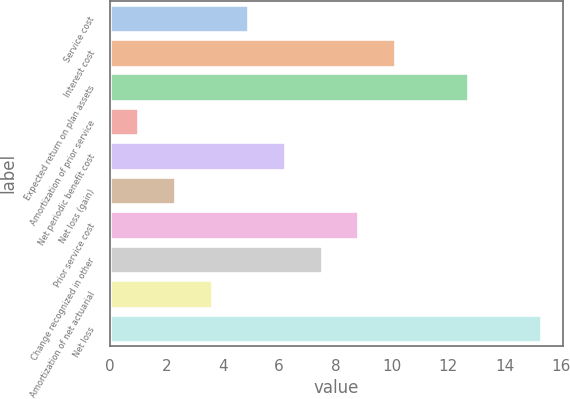Convert chart. <chart><loc_0><loc_0><loc_500><loc_500><bar_chart><fcel>Service cost<fcel>Interest cost<fcel>Expected return on plan assets<fcel>Amortization of prior service<fcel>Net periodic benefit cost<fcel>Net loss (gain)<fcel>Prior service cost<fcel>Change recognized in other<fcel>Amortization of net actuarial<fcel>Net loss<nl><fcel>4.9<fcel>10.1<fcel>12.7<fcel>1<fcel>6.2<fcel>2.3<fcel>8.8<fcel>7.5<fcel>3.6<fcel>15.3<nl></chart> 